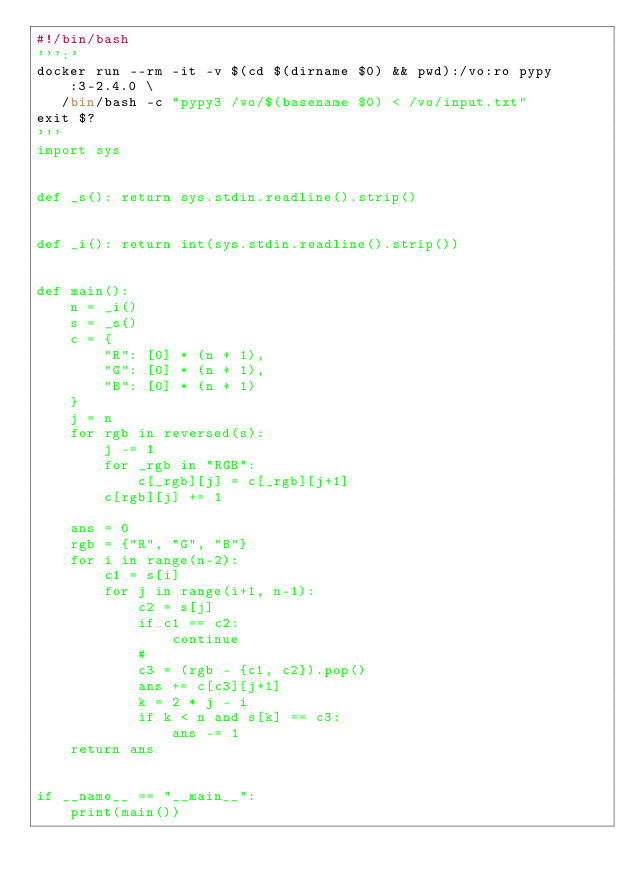Convert code to text. <code><loc_0><loc_0><loc_500><loc_500><_Python_>#!/bin/bash
''':'
docker run --rm -it -v $(cd $(dirname $0) && pwd):/vo:ro pypy:3-2.4.0 \
   /bin/bash -c "pypy3 /vo/$(basename $0) < /vo/input.txt"
exit $?
'''
import sys


def _s(): return sys.stdin.readline().strip()


def _i(): return int(sys.stdin.readline().strip())


def main():
    n = _i()
    s = _s()
    c = {
        "R": [0] * (n + 1),
        "G": [0] * (n + 1),
        "B": [0] * (n + 1)
    }
    j = n
    for rgb in reversed(s):
        j -= 1
        for _rgb in "RGB":
            c[_rgb][j] = c[_rgb][j+1]
        c[rgb][j] += 1

    ans = 0
    rgb = {"R", "G", "B"}
    for i in range(n-2):
        c1 = s[i]
        for j in range(i+1, n-1):
            c2 = s[j]
            if c1 == c2:
                continue
            #
            c3 = (rgb - {c1, c2}).pop()
            ans += c[c3][j+1]
            k = 2 * j - i
            if k < n and s[k] == c3:
                ans -= 1
    return ans


if __name__ == "__main__":
    print(main())
</code> 